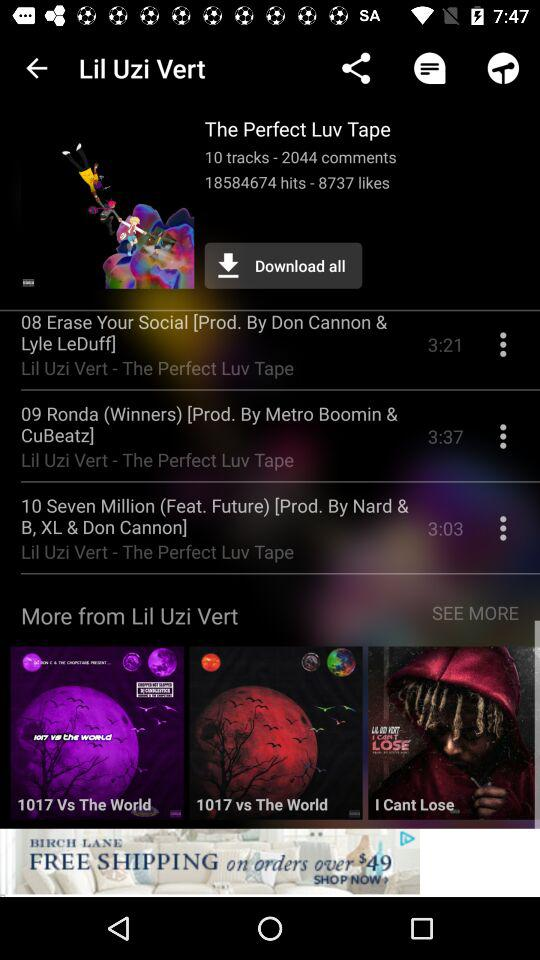Who is the prod. of "10 Seven Million"? The producers of "10 Seven Million" are Nard & B, XL & Don Cannon. 